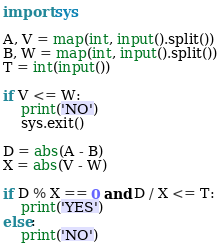<code> <loc_0><loc_0><loc_500><loc_500><_Python_>import sys

A, V = map(int, input().split())
B, W = map(int, input().split())
T = int(input())

if V <= W:
    print('NO')
    sys.exit()

D = abs(A - B)
X = abs(V - W)

if D % X == 0 and D / X <= T:
    print('YES')
else:
    print('NO')
</code> 